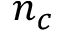Convert formula to latex. <formula><loc_0><loc_0><loc_500><loc_500>n _ { c }</formula> 